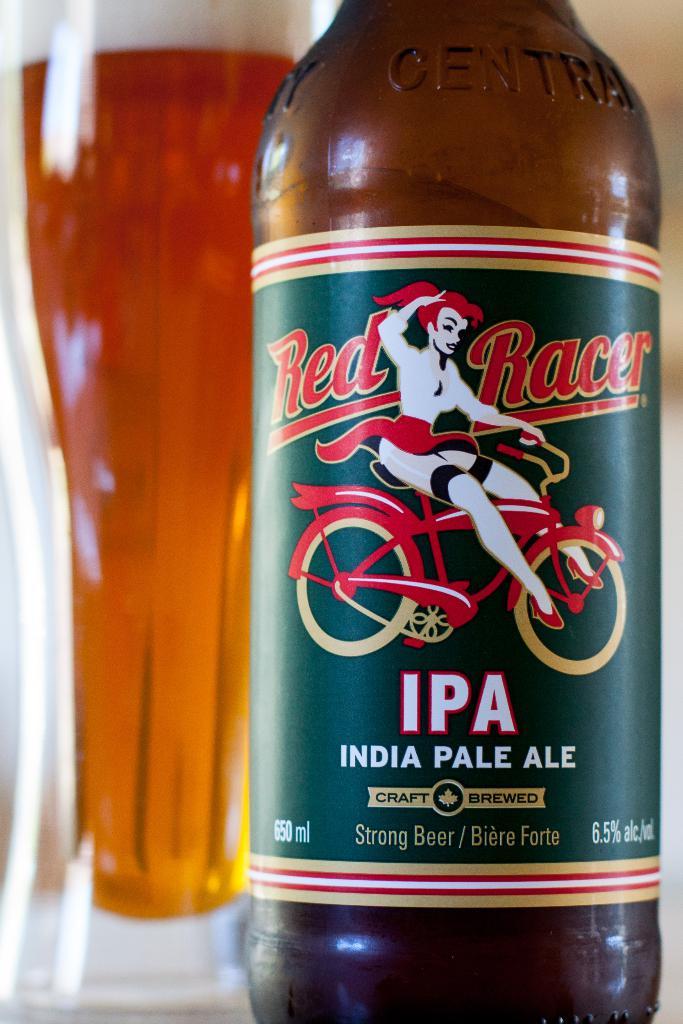Who makes the india pale ale?
Keep it short and to the point. Red racer. What percentage of alchol is in this?
Make the answer very short. 6.5. 